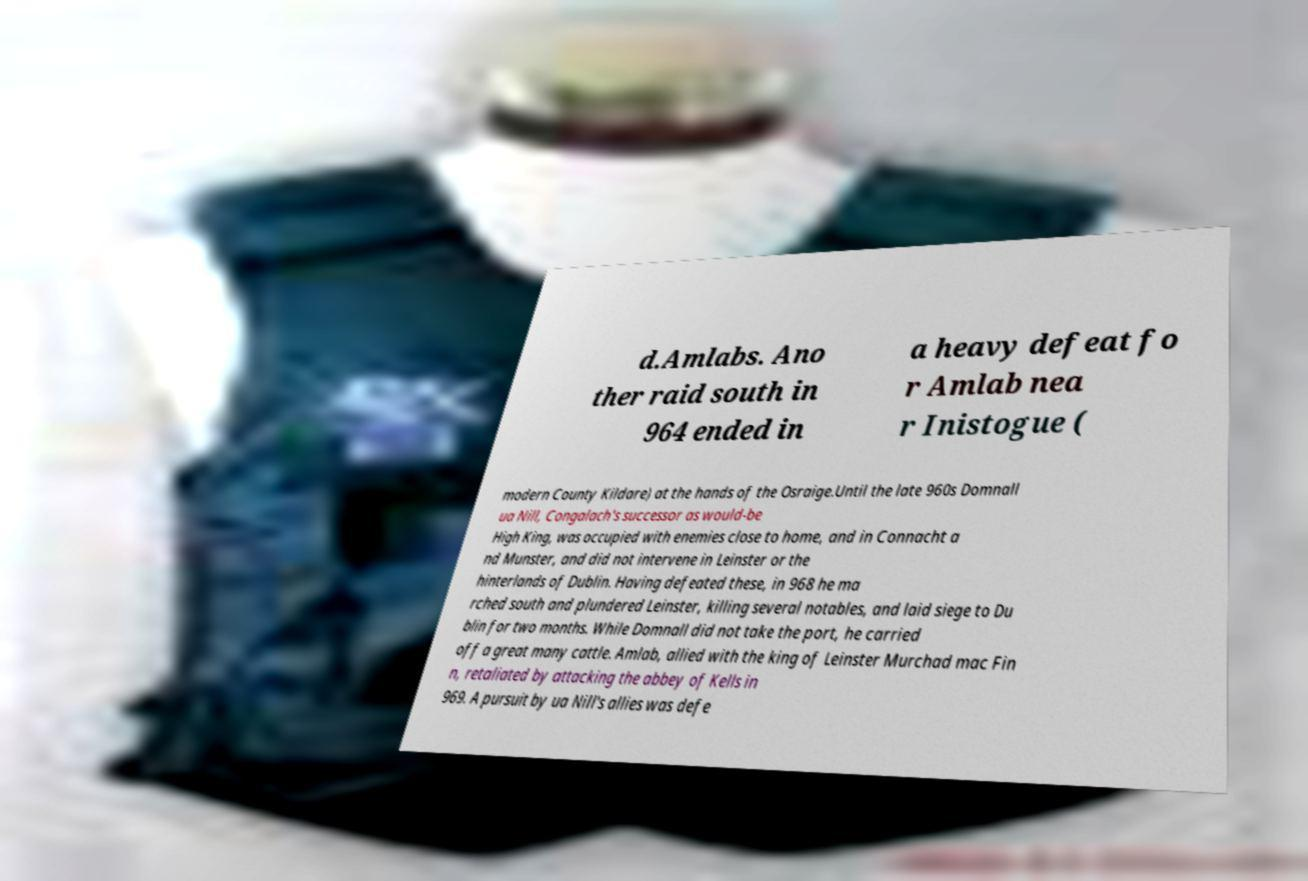For documentation purposes, I need the text within this image transcribed. Could you provide that? d.Amlabs. Ano ther raid south in 964 ended in a heavy defeat fo r Amlab nea r Inistogue ( modern County Kildare) at the hands of the Osraige.Until the late 960s Domnall ua Nill, Congalach's successor as would-be High King, was occupied with enemies close to home, and in Connacht a nd Munster, and did not intervene in Leinster or the hinterlands of Dublin. Having defeated these, in 968 he ma rched south and plundered Leinster, killing several notables, and laid siege to Du blin for two months. While Domnall did not take the port, he carried off a great many cattle. Amlab, allied with the king of Leinster Murchad mac Fin n, retaliated by attacking the abbey of Kells in 969. A pursuit by ua Nill's allies was defe 